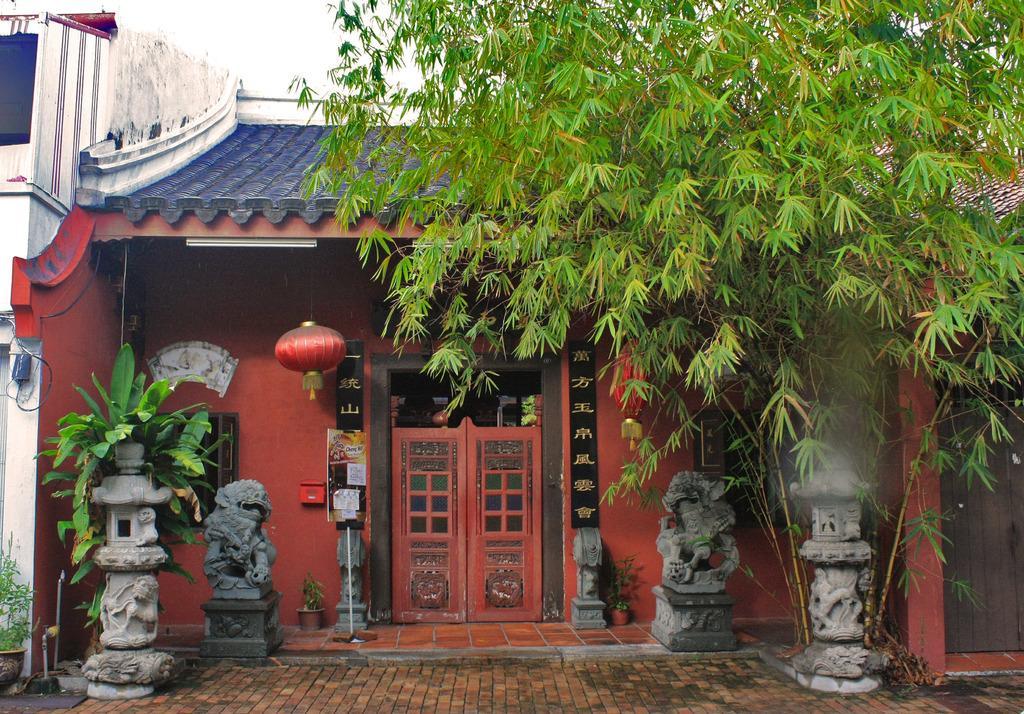Can you describe this image briefly? In the image we can see the tree and the plants. Here we can see the house, sculptures, floor and the sky. 